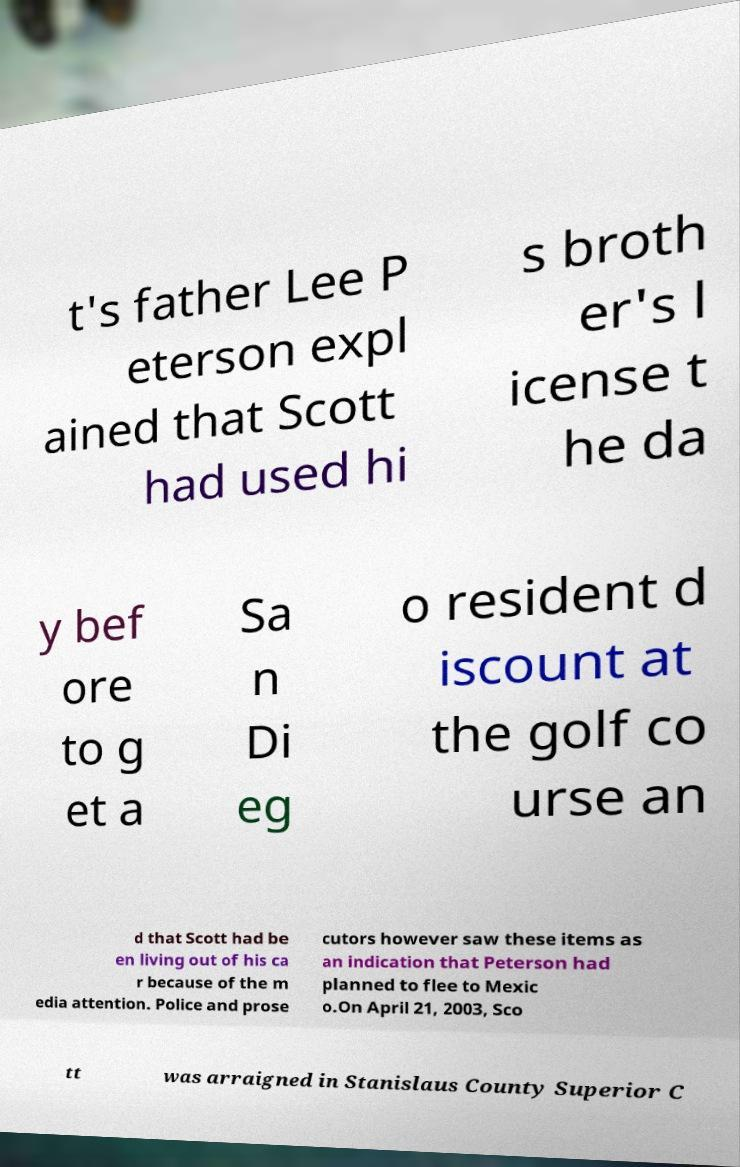Please read and relay the text visible in this image. What does it say? t's father Lee P eterson expl ained that Scott had used hi s broth er's l icense t he da y bef ore to g et a Sa n Di eg o resident d iscount at the golf co urse an d that Scott had be en living out of his ca r because of the m edia attention. Police and prose cutors however saw these items as an indication that Peterson had planned to flee to Mexic o.On April 21, 2003, Sco tt was arraigned in Stanislaus County Superior C 